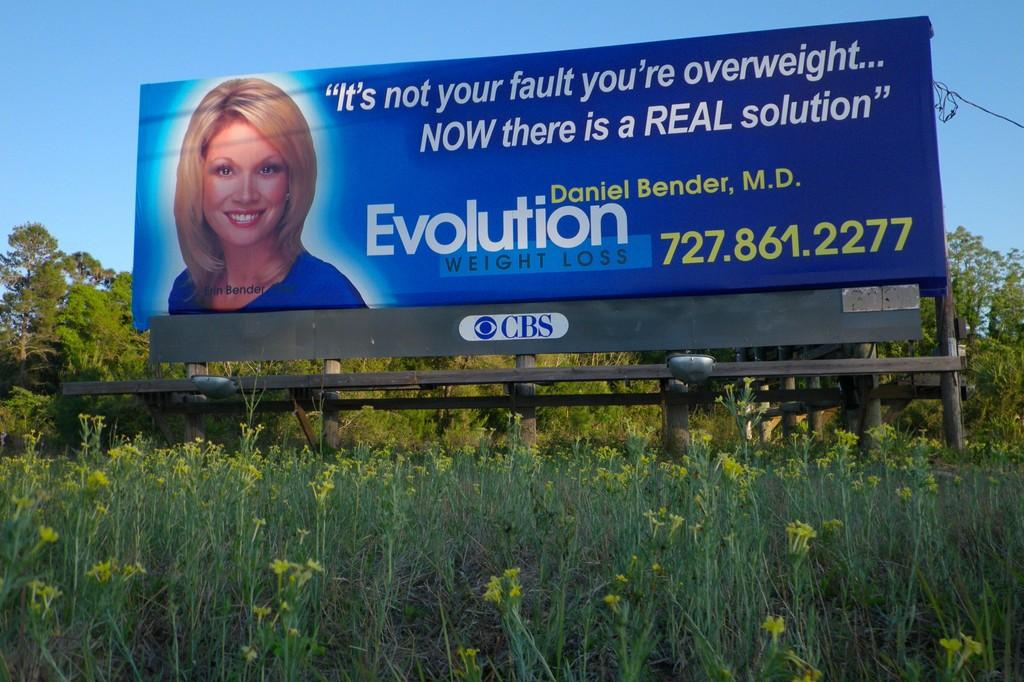Provide a one-sentence caption for the provided image. An advertisement for Evolution Weight Loss shows a smiling woman next to the phone number. 